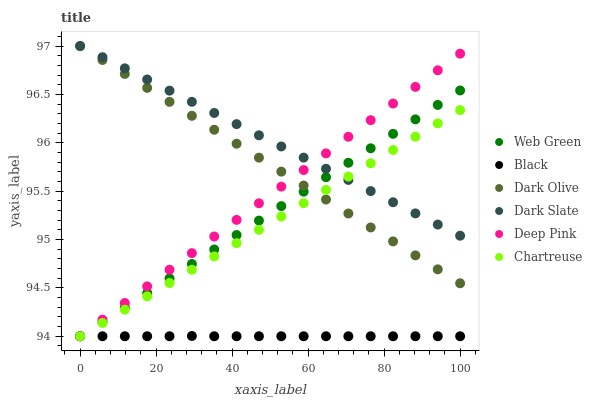Does Black have the minimum area under the curve?
Answer yes or no. Yes. Does Dark Slate have the maximum area under the curve?
Answer yes or no. Yes. Does Dark Olive have the minimum area under the curve?
Answer yes or no. No. Does Dark Olive have the maximum area under the curve?
Answer yes or no. No. Is Chartreuse the smoothest?
Answer yes or no. Yes. Is Black the roughest?
Answer yes or no. Yes. Is Dark Olive the smoothest?
Answer yes or no. No. Is Dark Olive the roughest?
Answer yes or no. No. Does Deep Pink have the lowest value?
Answer yes or no. Yes. Does Dark Olive have the lowest value?
Answer yes or no. No. Does Dark Slate have the highest value?
Answer yes or no. Yes. Does Web Green have the highest value?
Answer yes or no. No. Is Black less than Dark Slate?
Answer yes or no. Yes. Is Dark Olive greater than Black?
Answer yes or no. Yes. Does Deep Pink intersect Chartreuse?
Answer yes or no. Yes. Is Deep Pink less than Chartreuse?
Answer yes or no. No. Is Deep Pink greater than Chartreuse?
Answer yes or no. No. Does Black intersect Dark Slate?
Answer yes or no. No. 